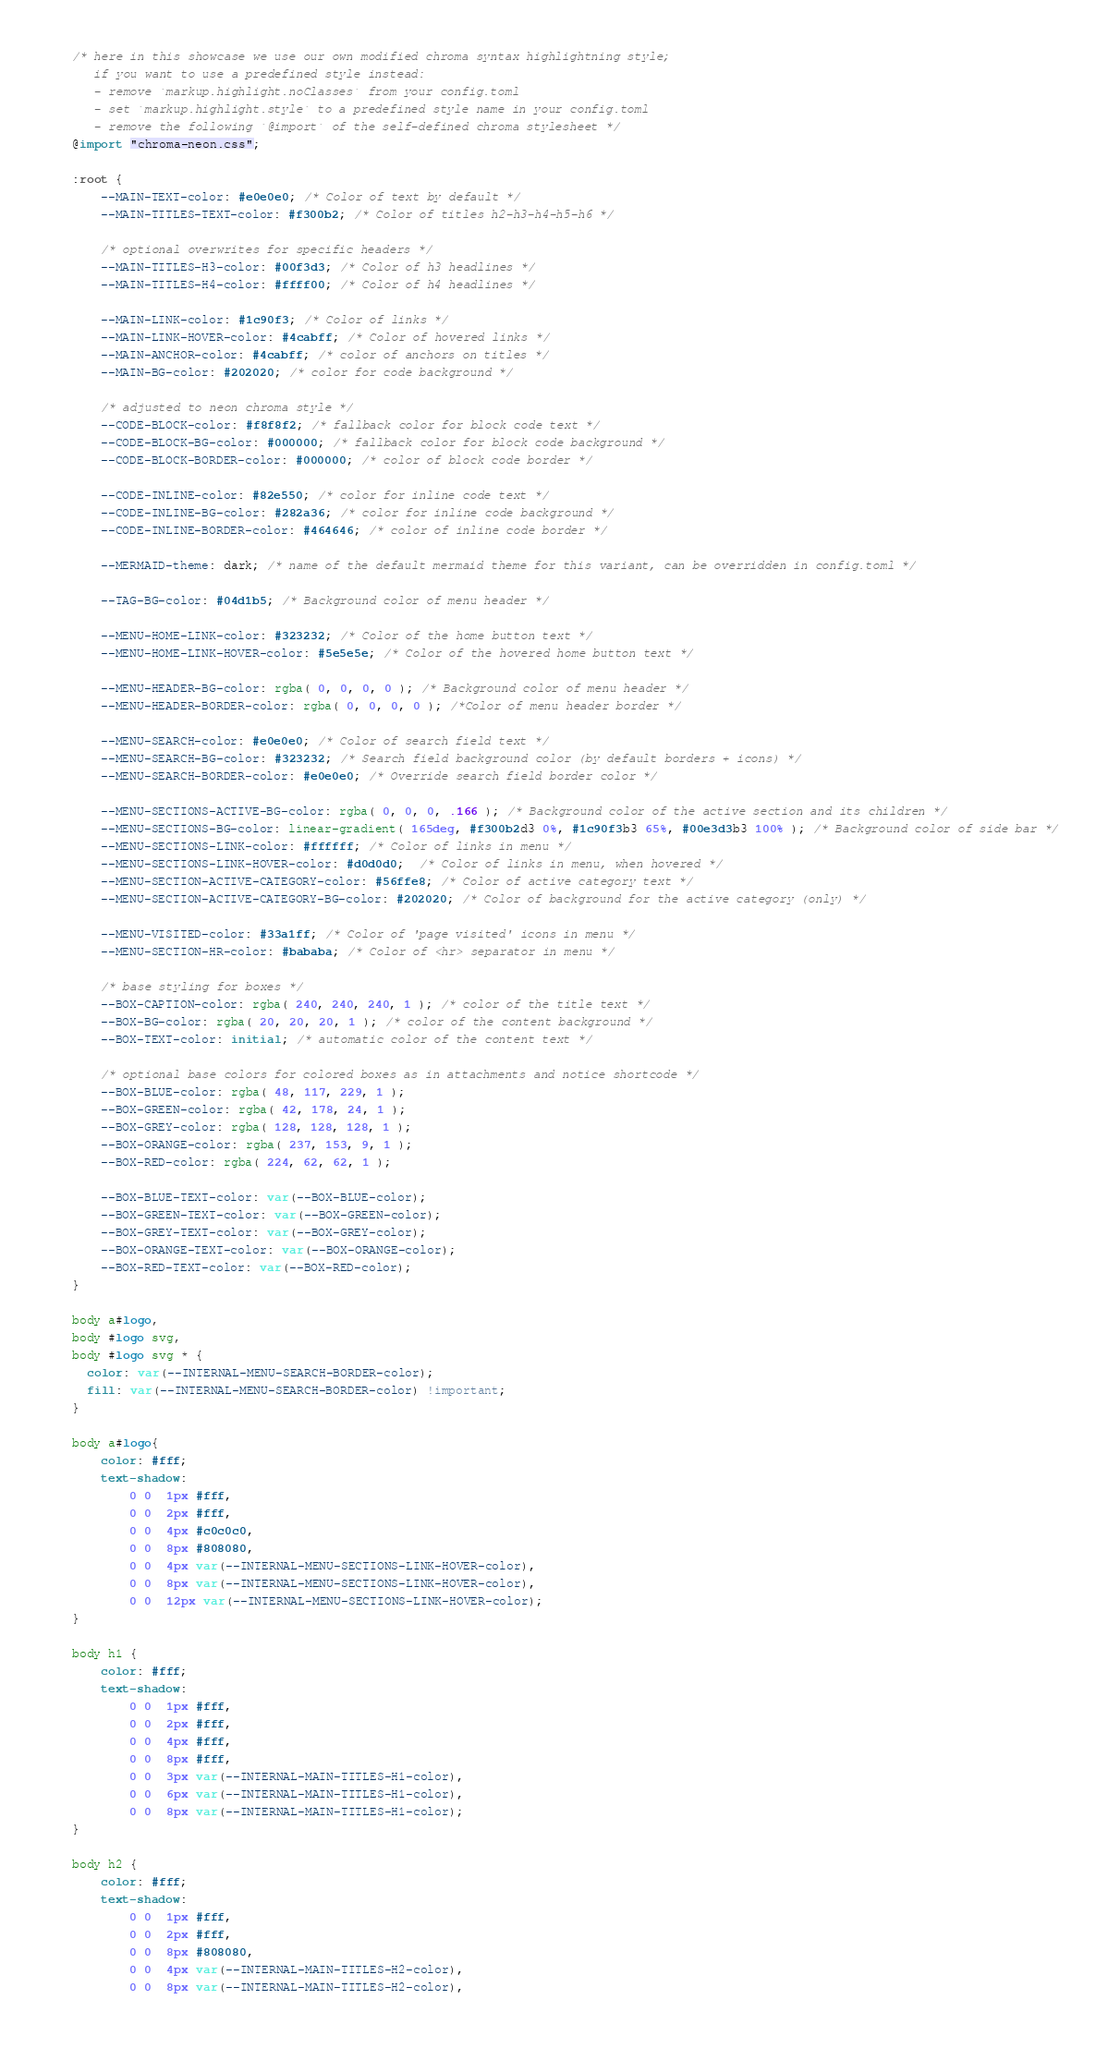<code> <loc_0><loc_0><loc_500><loc_500><_CSS_>/* here in this showcase we use our own modified chroma syntax highlightning style;
   if you want to use a predefined style instead:
   - remove `markup.highlight.noClasses` from your config.toml
   - set `markup.highlight.style` to a predefined style name in your config.toml
   - remove the following `@import` of the self-defined chroma stylesheet */
@import "chroma-neon.css";

:root {
    --MAIN-TEXT-color: #e0e0e0; /* Color of text by default */
    --MAIN-TITLES-TEXT-color: #f300b2; /* Color of titles h2-h3-h4-h5-h6 */

    /* optional overwrites for specific headers */
    --MAIN-TITLES-H3-color: #00f3d3; /* Color of h3 headlines */
    --MAIN-TITLES-H4-color: #ffff00; /* Color of h4 headlines */

    --MAIN-LINK-color: #1c90f3; /* Color of links */
    --MAIN-LINK-HOVER-color: #4cabff; /* Color of hovered links */
    --MAIN-ANCHOR-color: #4cabff; /* color of anchors on titles */
    --MAIN-BG-color: #202020; /* color for code background */

    /* adjusted to neon chroma style */
    --CODE-BLOCK-color: #f8f8f2; /* fallback color for block code text */
    --CODE-BLOCK-BG-color: #000000; /* fallback color for block code background */
    --CODE-BLOCK-BORDER-color: #000000; /* color of block code border */

    --CODE-INLINE-color: #82e550; /* color for inline code text */
    --CODE-INLINE-BG-color: #282a36; /* color for inline code background */
    --CODE-INLINE-BORDER-color: #464646; /* color of inline code border */

    --MERMAID-theme: dark; /* name of the default mermaid theme for this variant, can be overridden in config.toml */

    --TAG-BG-color: #04d1b5; /* Background color of menu header */

    --MENU-HOME-LINK-color: #323232; /* Color of the home button text */
    --MENU-HOME-LINK-HOVER-color: #5e5e5e; /* Color of the hovered home button text */

    --MENU-HEADER-BG-color: rgba( 0, 0, 0, 0 ); /* Background color of menu header */
    --MENU-HEADER-BORDER-color: rgba( 0, 0, 0, 0 ); /*Color of menu header border */

    --MENU-SEARCH-color: #e0e0e0; /* Color of search field text */
    --MENU-SEARCH-BG-color: #323232; /* Search field background color (by default borders + icons) */
    --MENU-SEARCH-BORDER-color: #e0e0e0; /* Override search field border color */

    --MENU-SECTIONS-ACTIVE-BG-color: rgba( 0, 0, 0, .166 ); /* Background color of the active section and its children */
    --MENU-SECTIONS-BG-color: linear-gradient( 165deg, #f300b2d3 0%, #1c90f3b3 65%, #00e3d3b3 100% ); /* Background color of side bar */
    --MENU-SECTIONS-LINK-color: #ffffff; /* Color of links in menu */
    --MENU-SECTIONS-LINK-HOVER-color: #d0d0d0;  /* Color of links in menu, when hovered */
    --MENU-SECTION-ACTIVE-CATEGORY-color: #56ffe8; /* Color of active category text */
    --MENU-SECTION-ACTIVE-CATEGORY-BG-color: #202020; /* Color of background for the active category (only) */

    --MENU-VISITED-color: #33a1ff; /* Color of 'page visited' icons in menu */
    --MENU-SECTION-HR-color: #bababa; /* Color of <hr> separator in menu */

    /* base styling for boxes */
    --BOX-CAPTION-color: rgba( 240, 240, 240, 1 ); /* color of the title text */
    --BOX-BG-color: rgba( 20, 20, 20, 1 ); /* color of the content background */
    --BOX-TEXT-color: initial; /* automatic color of the content text */

    /* optional base colors for colored boxes as in attachments and notice shortcode */
    --BOX-BLUE-color: rgba( 48, 117, 229, 1 );
    --BOX-GREEN-color: rgba( 42, 178, 24, 1 );
    --BOX-GREY-color: rgba( 128, 128, 128, 1 );
    --BOX-ORANGE-color: rgba( 237, 153, 9, 1 );
    --BOX-RED-color: rgba( 224, 62, 62, 1 );

    --BOX-BLUE-TEXT-color: var(--BOX-BLUE-color);
    --BOX-GREEN-TEXT-color: var(--BOX-GREEN-color);
    --BOX-GREY-TEXT-color: var(--BOX-GREY-color);
    --BOX-ORANGE-TEXT-color: var(--BOX-ORANGE-color);
    --BOX-RED-TEXT-color: var(--BOX-RED-color);
}

body a#logo,
body #logo svg,
body #logo svg * {
  color: var(--INTERNAL-MENU-SEARCH-BORDER-color);
  fill: var(--INTERNAL-MENU-SEARCH-BORDER-color) !important;
}

body a#logo{
    color: #fff;
    text-shadow:
        0 0  1px #fff,
        0 0  2px #fff,
        0 0  4px #c0c0c0,
        0 0  8px #808080,
        0 0  4px var(--INTERNAL-MENU-SECTIONS-LINK-HOVER-color),
        0 0  8px var(--INTERNAL-MENU-SECTIONS-LINK-HOVER-color),
        0 0  12px var(--INTERNAL-MENU-SECTIONS-LINK-HOVER-color);
}

body h1 {
    color: #fff;
    text-shadow:
        0 0  1px #fff,
        0 0  2px #fff,
        0 0  4px #fff,
        0 0  8px #fff,
        0 0  3px var(--INTERNAL-MAIN-TITLES-H1-color),
        0 0  6px var(--INTERNAL-MAIN-TITLES-H1-color),
        0 0  8px var(--INTERNAL-MAIN-TITLES-H1-color);
}

body h2 {
    color: #fff;
    text-shadow:
        0 0  1px #fff,
        0 0  2px #fff,
        0 0  8px #808080,
        0 0  4px var(--INTERNAL-MAIN-TITLES-H2-color),
        0 0  8px var(--INTERNAL-MAIN-TITLES-H2-color),</code> 